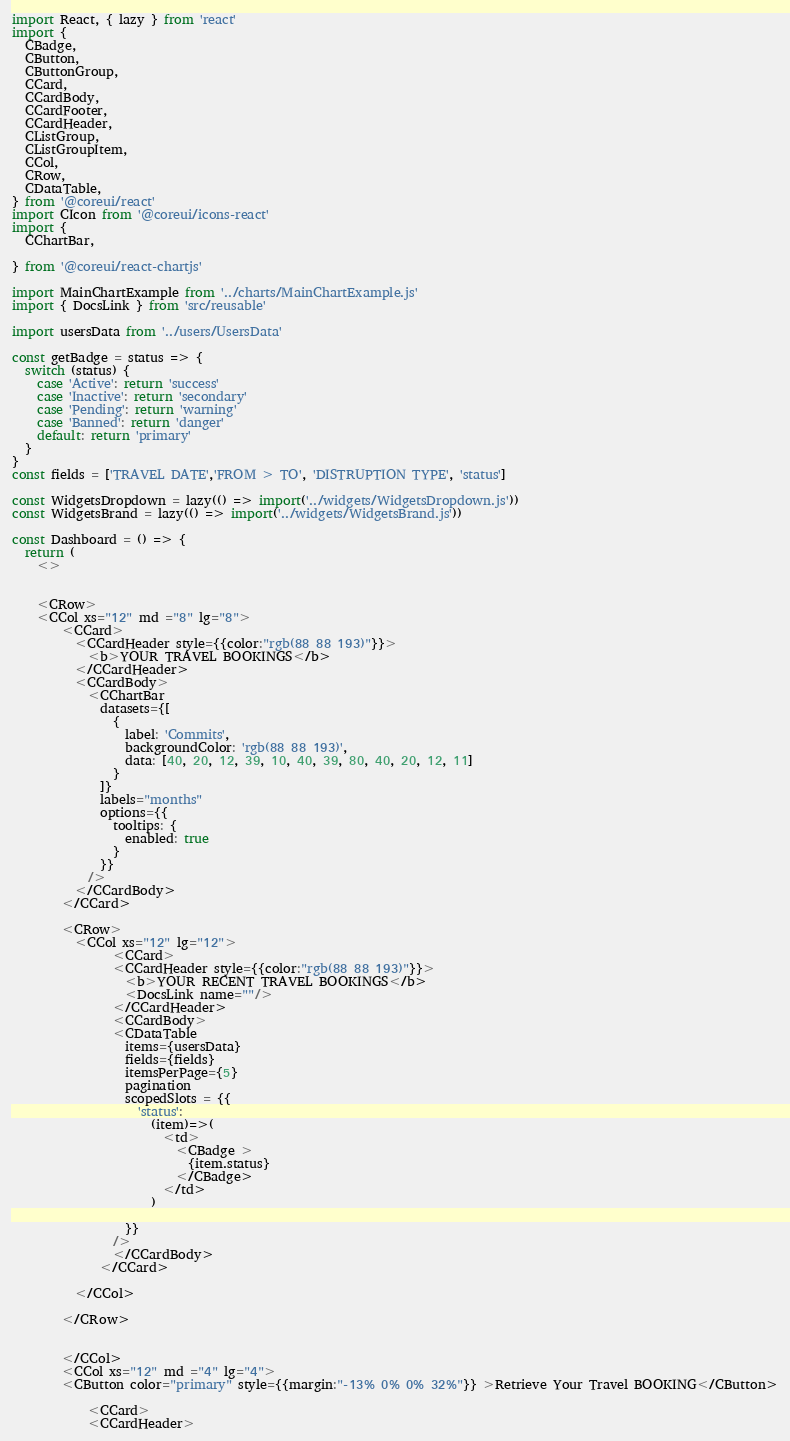<code> <loc_0><loc_0><loc_500><loc_500><_JavaScript_>import React, { lazy } from 'react'
import {
  CBadge,
  CButton,
  CButtonGroup,
  CCard,
  CCardBody,
  CCardFooter,
  CCardHeader,
  CListGroup,
  CListGroupItem,
  CCol,
  CRow,
  CDataTable,
} from '@coreui/react'
import CIcon from '@coreui/icons-react'
import {
  CChartBar,

} from '@coreui/react-chartjs'

import MainChartExample from '../charts/MainChartExample.js'
import { DocsLink } from 'src/reusable'

import usersData from '../users/UsersData'

const getBadge = status => {
  switch (status) {
    case 'Active': return 'success'
    case 'Inactive': return 'secondary'
    case 'Pending': return 'warning'
    case 'Banned': return 'danger'
    default: return 'primary'
  }
}
const fields = ['TRAVEL DATE','FROM > TO', 'DISTRUPTION TYPE', 'status']

const WidgetsDropdown = lazy(() => import('../widgets/WidgetsDropdown.js'))
const WidgetsBrand = lazy(() => import('../widgets/WidgetsBrand.js'))

const Dashboard = () => {
  return (
    <>
    
      
    <CRow>
    <CCol xs="12" md ="8" lg="8">
        <CCard>
          <CCardHeader style={{color:"rgb(88 88 193)"}}>
            <b>YOUR TRAVEL BOOKINGS</b>
          </CCardHeader>
          <CCardBody>
            <CChartBar
              datasets={[
                {
                  label: 'Commits',
                  backgroundColor: 'rgb(88 88 193)',
                  data: [40, 20, 12, 39, 10, 40, 39, 80, 40, 20, 12, 11]
                }
              ]}
              labels="months"
              options={{
                tooltips: {
                  enabled: true
                }
              }}
            />
          </CCardBody>
        </CCard>
        
        <CRow>
          <CCol xs="12" lg="12">
                <CCard>
                <CCardHeader style={{color:"rgb(88 88 193)"}}>
                  <b>YOUR RECENT TRAVEL BOOKINGS</b>
                  <DocsLink name=""/>
                </CCardHeader>
                <CCardBody>
                <CDataTable
                  items={usersData}
                  fields={fields}
                  itemsPerPage={5}
                  pagination
                  scopedSlots = {{
                    'status':
                      (item)=>(
                        <td>
                          <CBadge >
                            {item.status}
                          </CBadge>
                        </td>
                      )

                  }}
                />
                </CCardBody>
              </CCard>
             
          </CCol>  
        
        </CRow> 
       

        </CCol>
        <CCol xs="12" md ="4" lg="4">
        <CButton color="primary" style={{margin:"-13% 0% 0% 32%"}} >Retrieve Your Travel BOOKING</CButton>
        
            <CCard>
            <CCardHeader></code> 